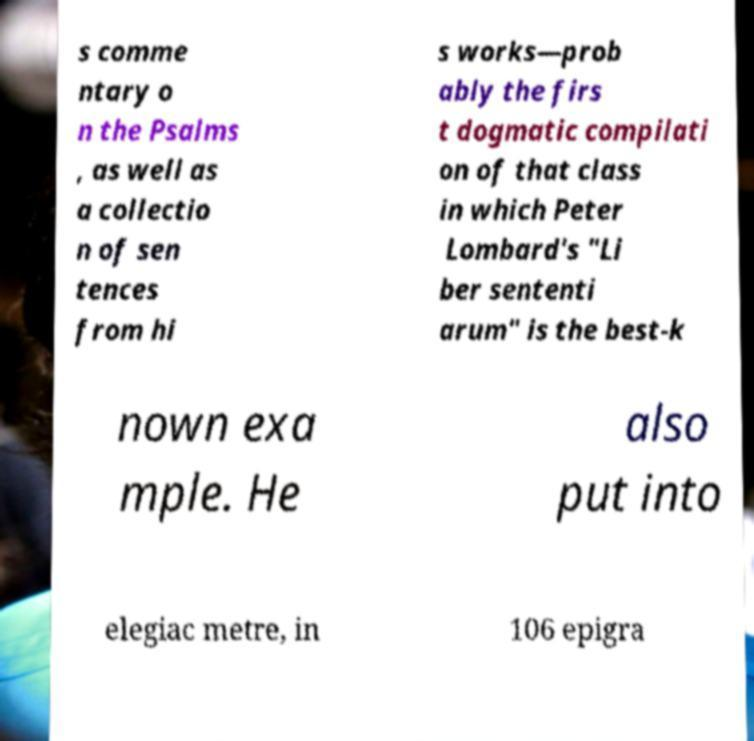Please identify and transcribe the text found in this image. s comme ntary o n the Psalms , as well as a collectio n of sen tences from hi s works—prob ably the firs t dogmatic compilati on of that class in which Peter Lombard's "Li ber sententi arum" is the best-k nown exa mple. He also put into elegiac metre, in 106 epigra 